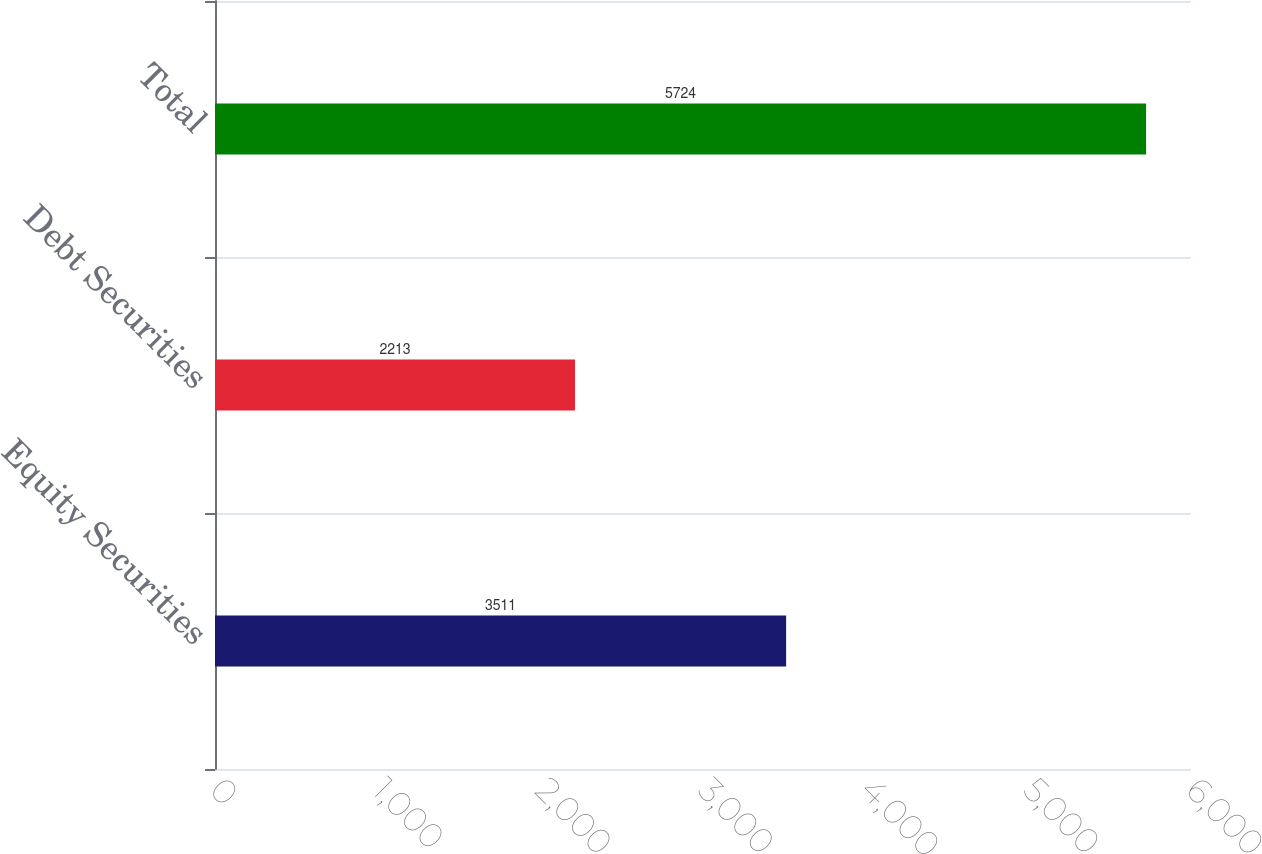Convert chart to OTSL. <chart><loc_0><loc_0><loc_500><loc_500><bar_chart><fcel>Equity Securities<fcel>Debt Securities<fcel>Total<nl><fcel>3511<fcel>2213<fcel>5724<nl></chart> 